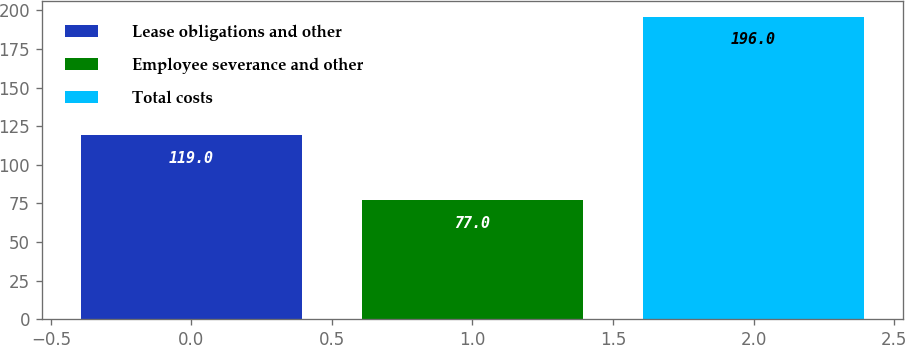Convert chart. <chart><loc_0><loc_0><loc_500><loc_500><bar_chart><fcel>Lease obligations and other<fcel>Employee severance and other<fcel>Total costs<nl><fcel>119<fcel>77<fcel>196<nl></chart> 